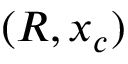<formula> <loc_0><loc_0><loc_500><loc_500>( R , x _ { c } )</formula> 